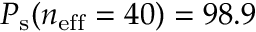<formula> <loc_0><loc_0><loc_500><loc_500>P _ { s } ( n _ { e f f } = 4 0 ) = 9 8 . 9 \</formula> 